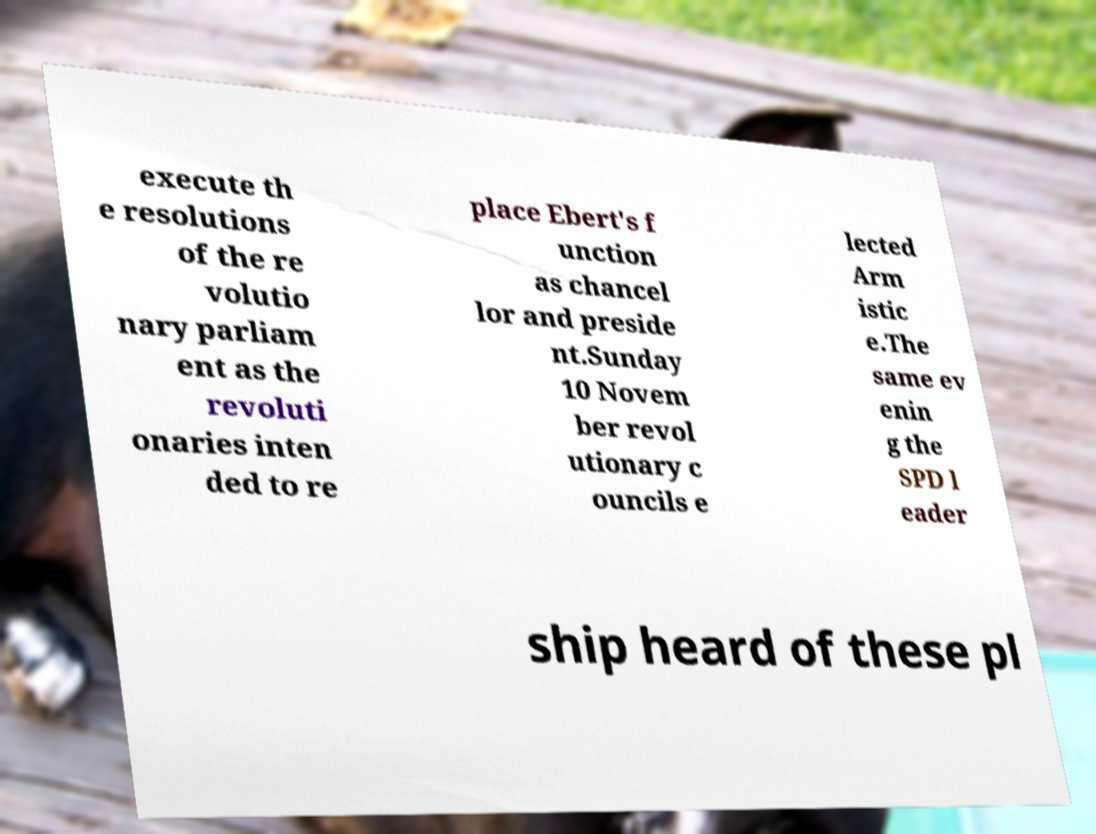Can you accurately transcribe the text from the provided image for me? execute th e resolutions of the re volutio nary parliam ent as the revoluti onaries inten ded to re place Ebert's f unction as chancel lor and preside nt.Sunday 10 Novem ber revol utionary c ouncils e lected Arm istic e.The same ev enin g the SPD l eader ship heard of these pl 